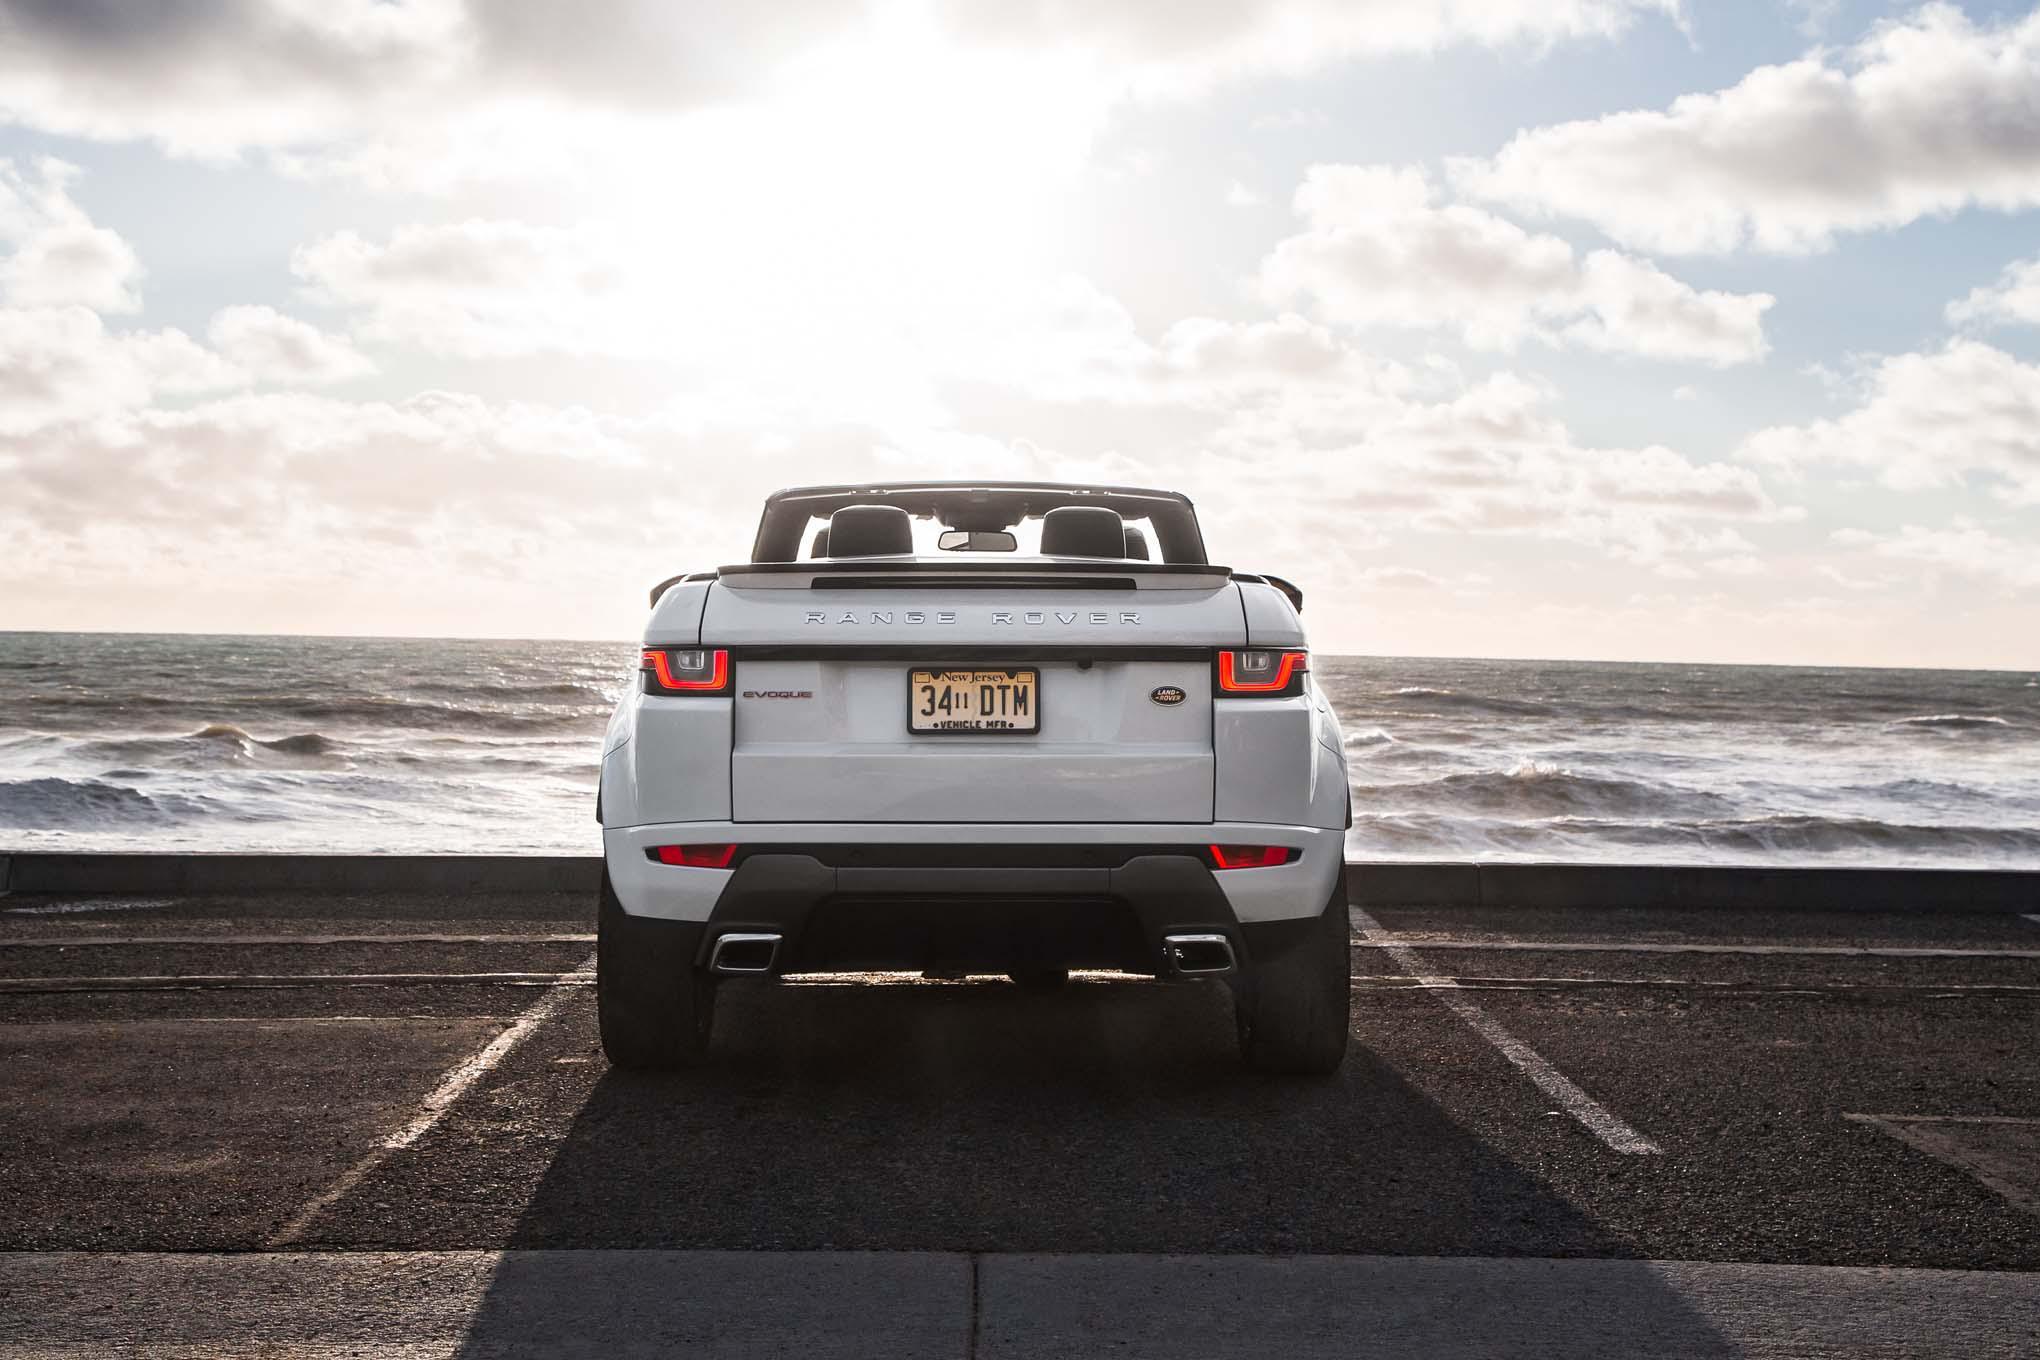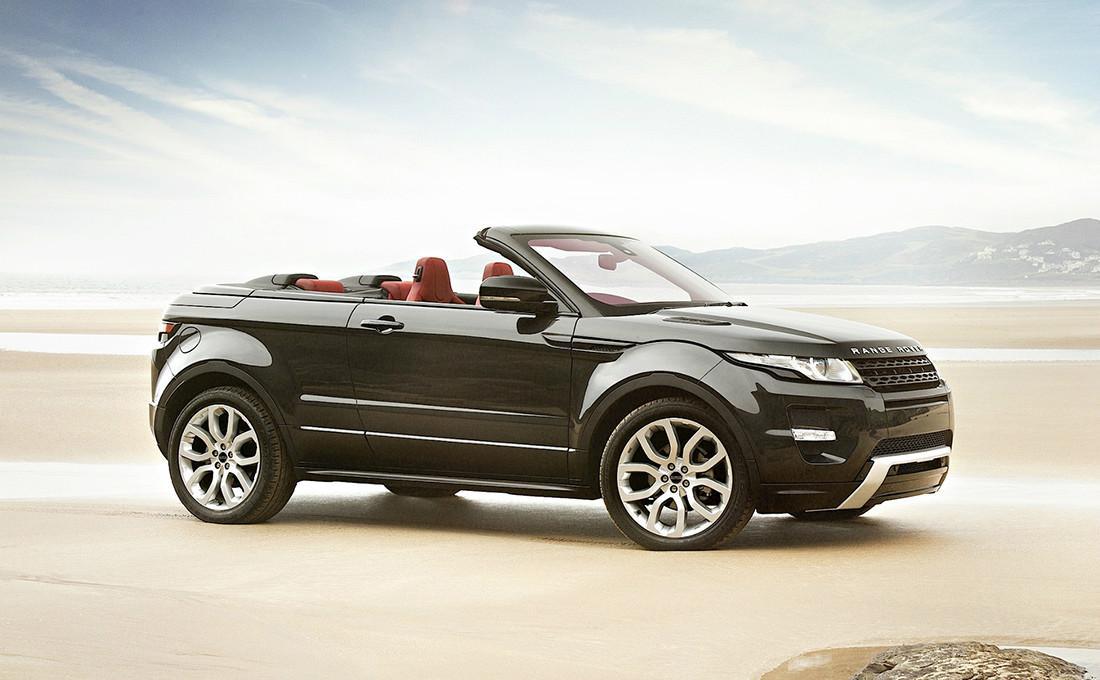The first image is the image on the left, the second image is the image on the right. For the images shown, is this caption "One of the images shows an orange vehicle." true? Answer yes or no. No. The first image is the image on the left, the second image is the image on the right. For the images shown, is this caption "a convertible is in a parking space overlooking the beach" true? Answer yes or no. Yes. 